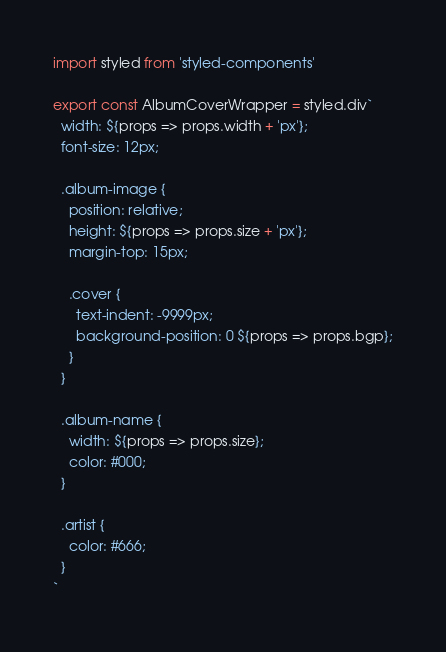Convert code to text. <code><loc_0><loc_0><loc_500><loc_500><_JavaScript_>import styled from 'styled-components'

export const AlbumCoverWrapper = styled.div`
  width: ${props => props.width + 'px'};
  font-size: 12px;

  .album-image {
    position: relative;
    height: ${props => props.size + 'px'};
    margin-top: 15px;
    
    .cover {
      text-indent: -9999px;
      background-position: 0 ${props => props.bgp};
    }
  }

  .album-name {
    width: ${props => props.size};
    color: #000;
  }

  .artist {
    color: #666;
  }
`
</code> 